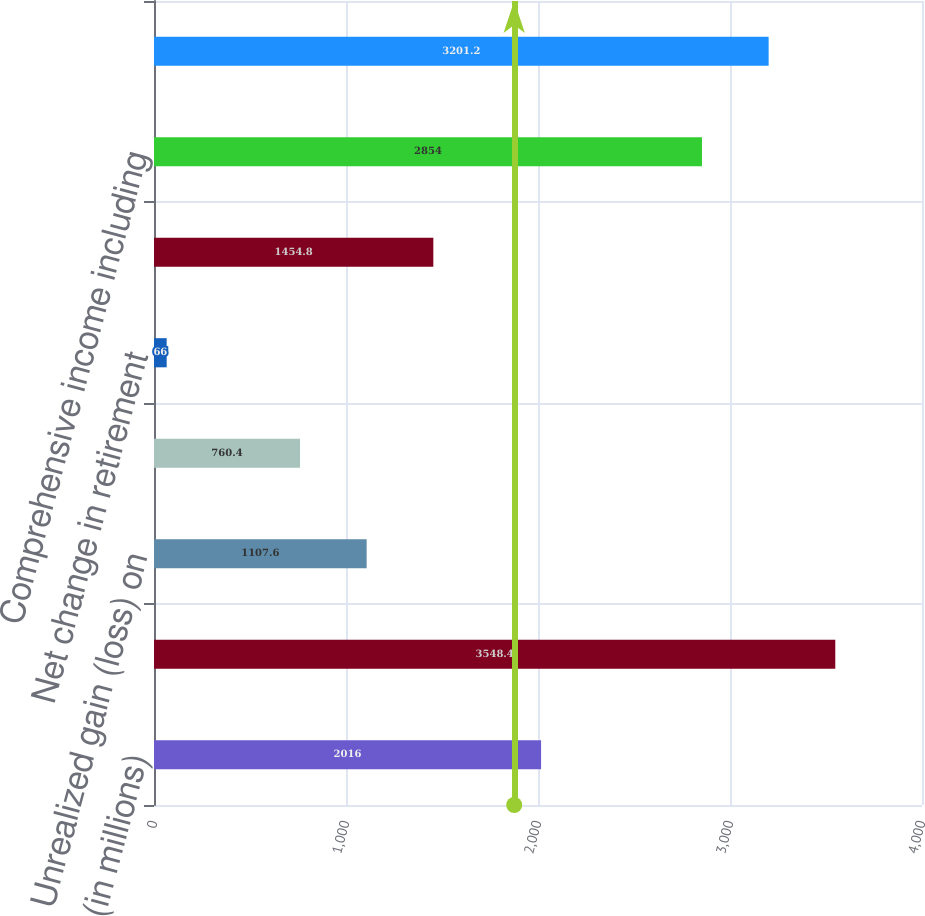<chart> <loc_0><loc_0><loc_500><loc_500><bar_chart><fcel>(in millions)<fcel>Net income<fcel>Unrealized gain (loss) on<fcel>Translation adjustment<fcel>Net change in retirement<fcel>Other comprehensive loss<fcel>Comprehensive income including<fcel>Comprehensive income<nl><fcel>2016<fcel>3548.4<fcel>1107.6<fcel>760.4<fcel>66<fcel>1454.8<fcel>2854<fcel>3201.2<nl></chart> 